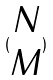Convert formula to latex. <formula><loc_0><loc_0><loc_500><loc_500>( \begin{matrix} N \\ M \end{matrix} )</formula> 